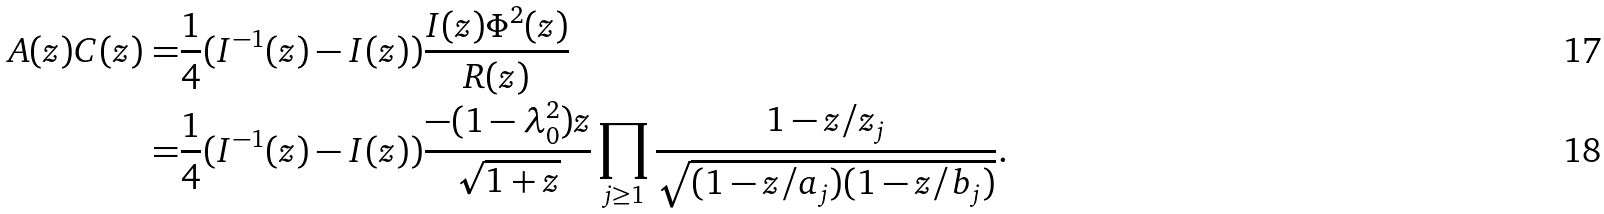<formula> <loc_0><loc_0><loc_500><loc_500>A ( z ) C ( z ) = & \frac { 1 } { 4 } ( I ^ { - 1 } ( z ) - I ( z ) ) \frac { I ( z ) \Phi ^ { 2 } ( z ) } { R ( z ) } \\ = & \frac { 1 } { 4 } ( I ^ { - 1 } ( z ) - I ( z ) ) \frac { - ( 1 - \lambda _ { 0 } ^ { 2 } ) z } { \sqrt { 1 + z } } \prod _ { j \geq 1 } \frac { 1 - z / z _ { j } } { \sqrt { ( 1 - z / a _ { j } ) ( 1 - z / b _ { j } ) } } .</formula> 